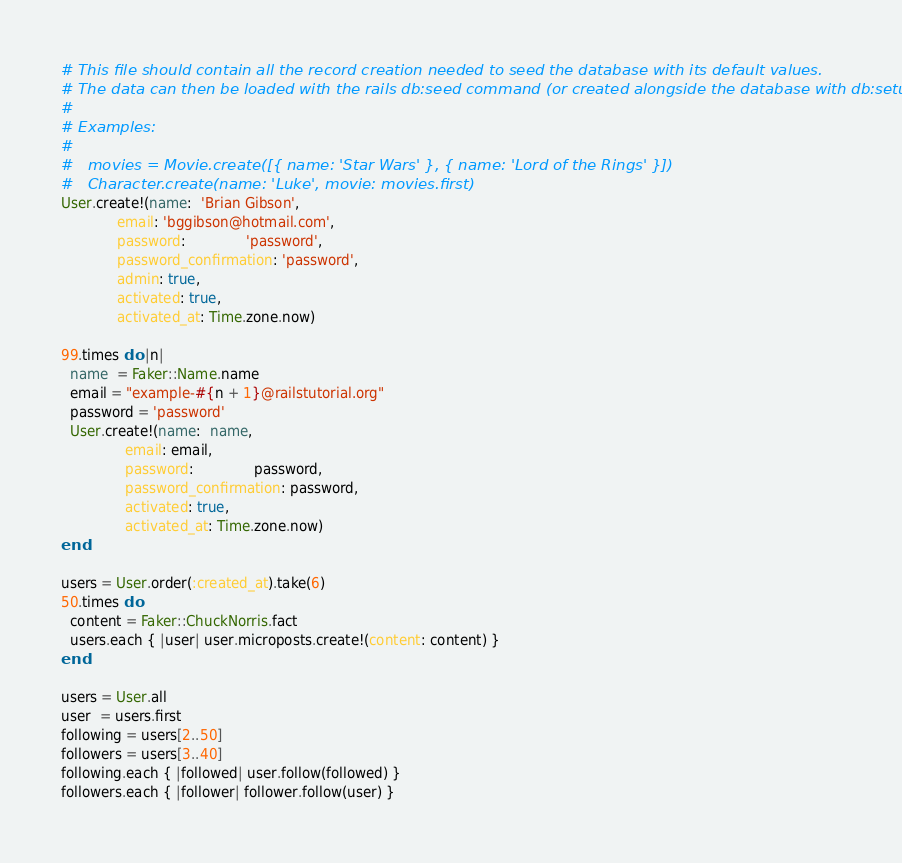<code> <loc_0><loc_0><loc_500><loc_500><_Ruby_># This file should contain all the record creation needed to seed the database with its default values.
# The data can then be loaded with the rails db:seed command (or created alongside the database with db:setup).
#
# Examples:
#
#   movies = Movie.create([{ name: 'Star Wars' }, { name: 'Lord of the Rings' }])
#   Character.create(name: 'Luke', movie: movies.first)
User.create!(name:  'Brian Gibson',
             email: 'bggibson@hotmail.com',
             password:              'password',
             password_confirmation: 'password',
             admin: true,
             activated: true,
             activated_at: Time.zone.now)

99.times do |n|
  name  = Faker::Name.name
  email = "example-#{n + 1}@railstutorial.org"
  password = 'password'
  User.create!(name:  name,
               email: email,
               password:              password,
               password_confirmation: password,
               activated: true,
               activated_at: Time.zone.now)
end

users = User.order(:created_at).take(6)
50.times do
  content = Faker::ChuckNorris.fact
  users.each { |user| user.microposts.create!(content: content) }
end

users = User.all
user  = users.first
following = users[2..50]
followers = users[3..40]
following.each { |followed| user.follow(followed) }
followers.each { |follower| follower.follow(user) }
</code> 